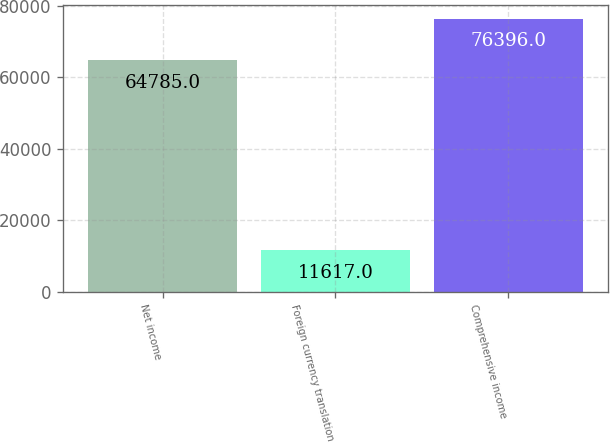Convert chart. <chart><loc_0><loc_0><loc_500><loc_500><bar_chart><fcel>Net income<fcel>Foreign currency translation<fcel>Comprehensive income<nl><fcel>64785<fcel>11617<fcel>76396<nl></chart> 